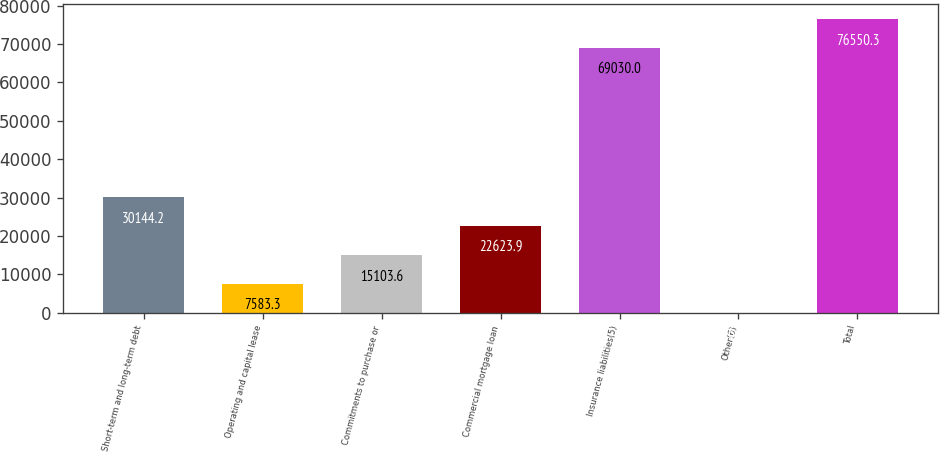<chart> <loc_0><loc_0><loc_500><loc_500><bar_chart><fcel>Short-term and long-term debt<fcel>Operating and capital lease<fcel>Commitments to purchase or<fcel>Commercial mortgage loan<fcel>Insurance liabilities(5)<fcel>Other(6)<fcel>Total<nl><fcel>30144.2<fcel>7583.3<fcel>15103.6<fcel>22623.9<fcel>69030<fcel>63<fcel>76550.3<nl></chart> 